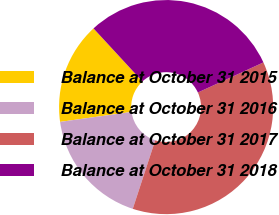Convert chart to OTSL. <chart><loc_0><loc_0><loc_500><loc_500><pie_chart><fcel>Balance at October 31 2015<fcel>Balance at October 31 2016<fcel>Balance at October 31 2017<fcel>Balance at October 31 2018<nl><fcel>15.34%<fcel>17.75%<fcel>36.89%<fcel>30.01%<nl></chart> 